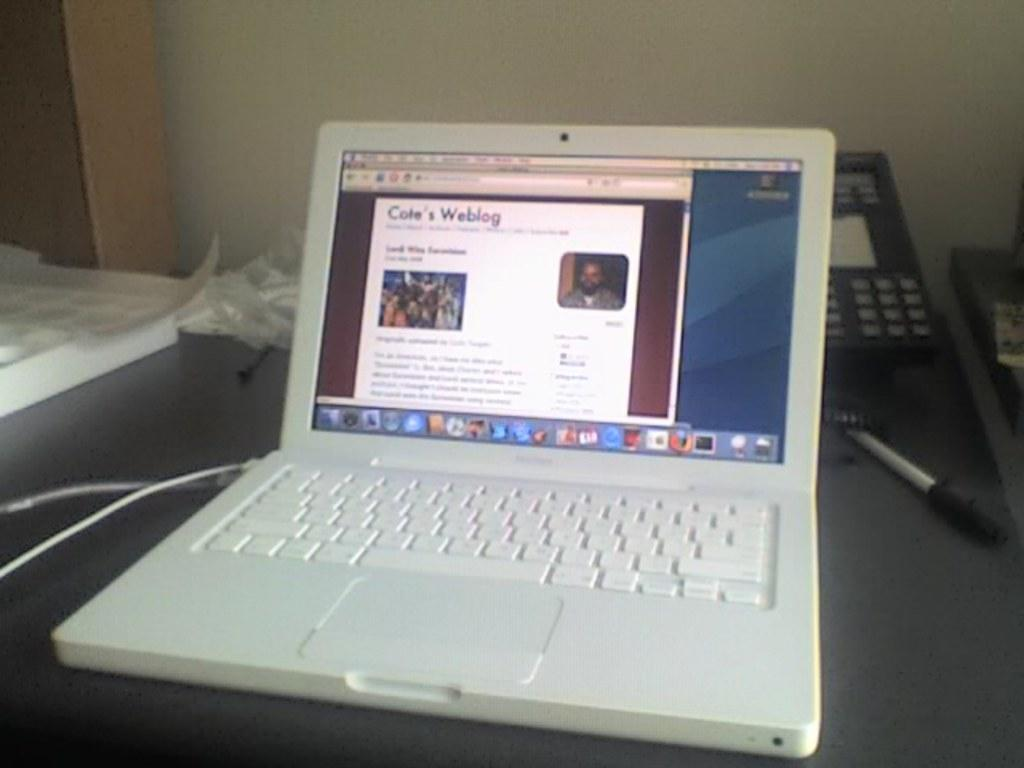<image>
Share a concise interpretation of the image provided. White laptop showing Cole's Wedding on the screen. 